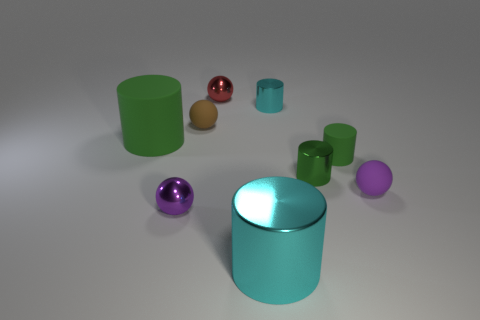There is a object that is both in front of the big green rubber cylinder and left of the brown sphere; what is its material?
Your answer should be very brief. Metal. How many red metallic objects are the same size as the purple matte ball?
Keep it short and to the point. 1. There is a matte cylinder on the right side of the cyan metallic cylinder in front of the tiny cyan shiny cylinder; what color is it?
Make the answer very short. Green. Is there a big metal object?
Your answer should be compact. Yes. Does the small brown rubber thing have the same shape as the small green metal object?
Ensure brevity in your answer.  No. The metallic cylinder that is the same color as the large metal thing is what size?
Your answer should be very brief. Small. What number of small cyan things are right of the green rubber cylinder right of the brown rubber ball?
Offer a very short reply. 0. What number of tiny metallic balls are both in front of the tiny red metal sphere and to the right of the small brown rubber object?
Give a very brief answer. 0. How many things are gray rubber spheres or green matte objects right of the big shiny object?
Offer a very short reply. 1. The purple thing that is the same material as the red object is what size?
Provide a succinct answer. Small. 